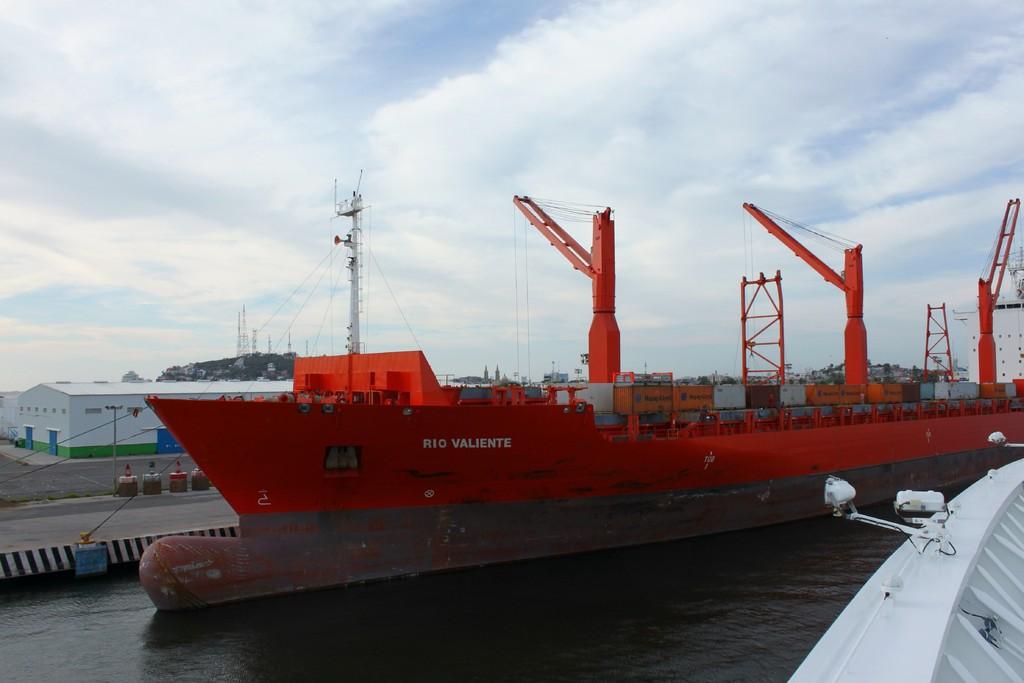What is the name of the ship?
Give a very brief answer. Rio valiente. 